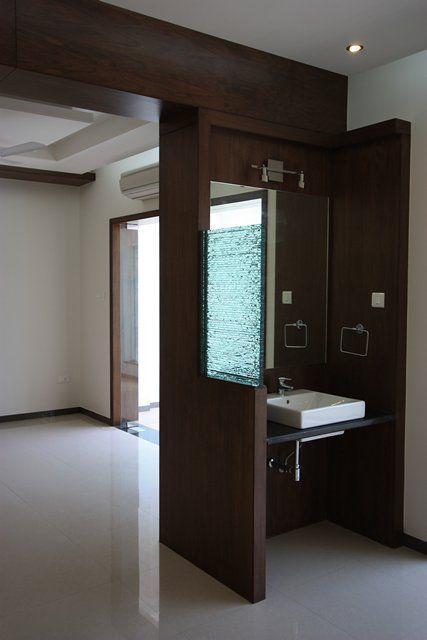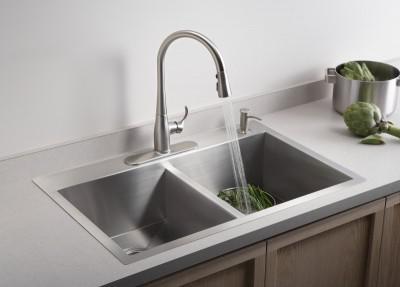The first image is the image on the left, the second image is the image on the right. Considering the images on both sides, is "Three faucets are attached directly to the sink porcelain." valid? Answer yes or no. No. The first image is the image on the left, the second image is the image on the right. Evaluate the accuracy of this statement regarding the images: "In total, three sink basins are shown.". Is it true? Answer yes or no. Yes. 